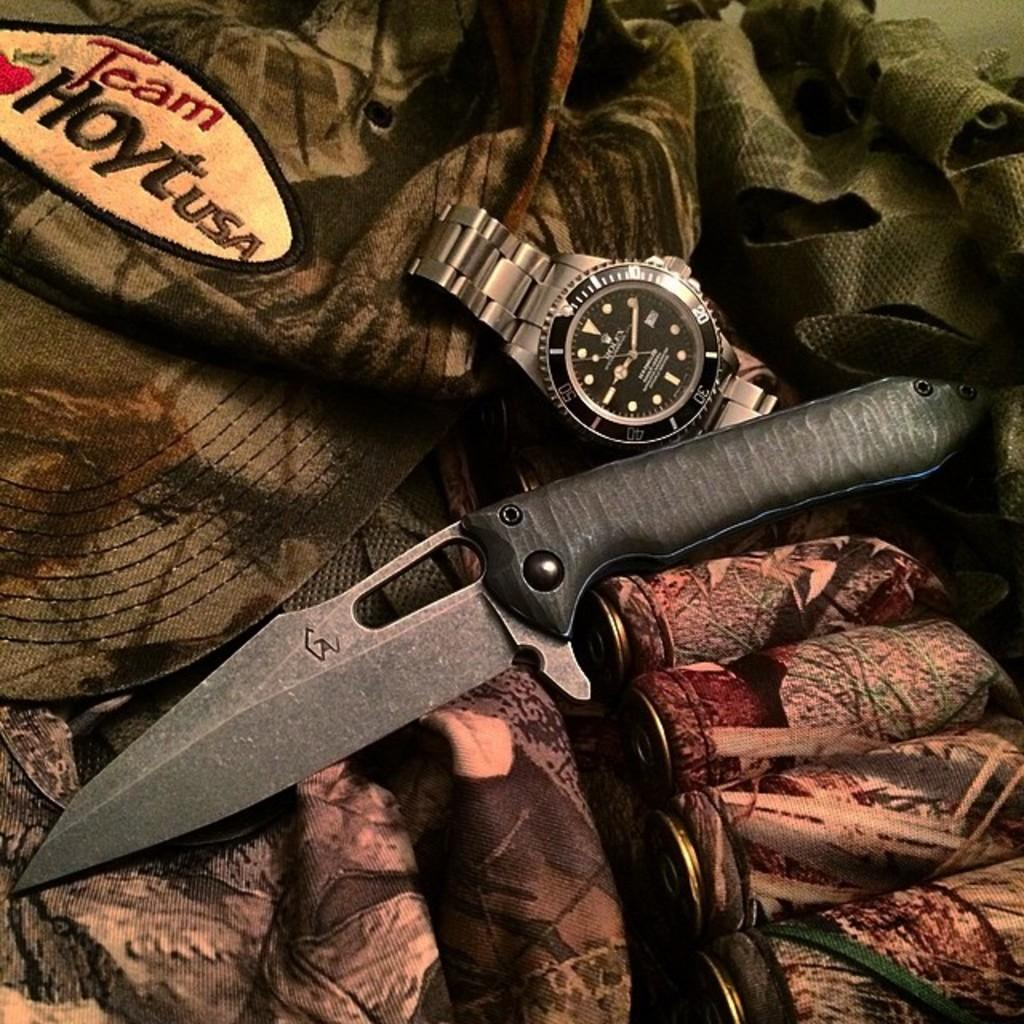What type of object can be seen in the image? There is a knife and a watch in the image. Where are the objects placed? The objects are placed on a cloth. What is the color of the cloth? The cloth is green in color. How does the knife make the room quieter in the image? The knife does not make the room quieter in the image; it is simply an object placed on a green cloth. 